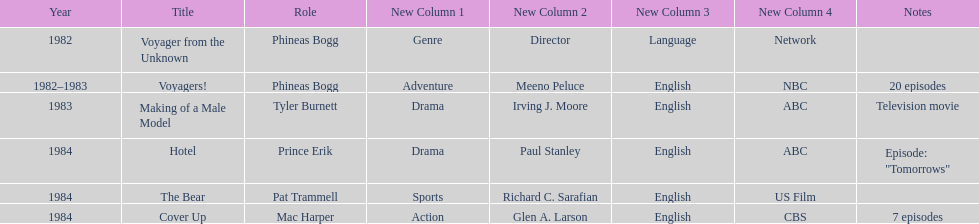Which year did he play the role of mac harper and also pat trammell? 1984. 